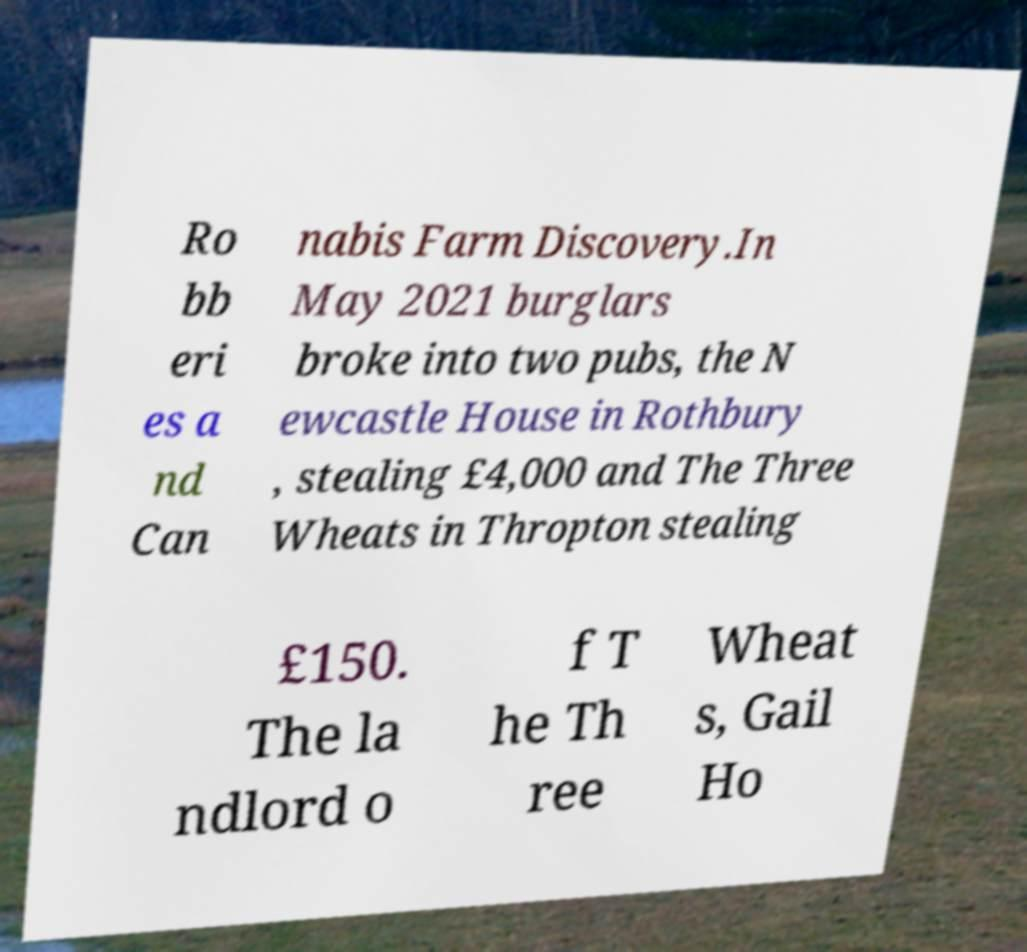Can you accurately transcribe the text from the provided image for me? Ro bb eri es a nd Can nabis Farm Discovery.In May 2021 burglars broke into two pubs, the N ewcastle House in Rothbury , stealing £4,000 and The Three Wheats in Thropton stealing £150. The la ndlord o f T he Th ree Wheat s, Gail Ho 